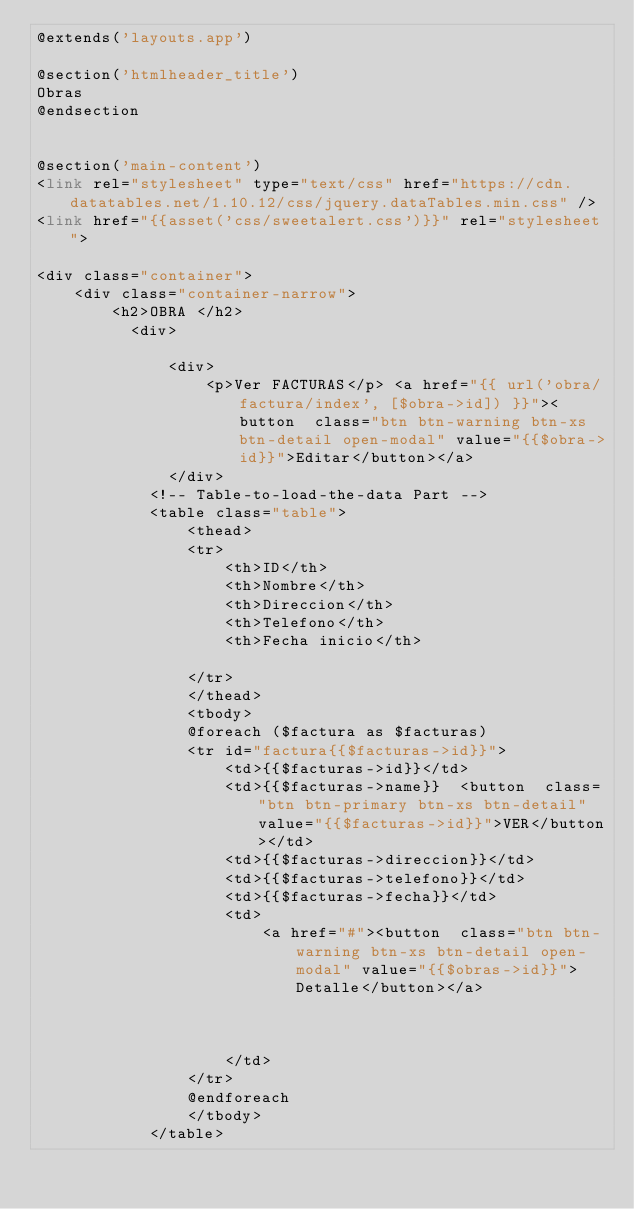Convert code to text. <code><loc_0><loc_0><loc_500><loc_500><_PHP_>@extends('layouts.app')

@section('htmlheader_title')
Obras
@endsection


@section('main-content')
<link rel="stylesheet" type="text/css" href="https://cdn.datatables.net/1.10.12/css/jquery.dataTables.min.css" />
<link href="{{asset('css/sweetalert.css')}}" rel="stylesheet">

<div class="container">
    <div class="container-narrow">
        <h2>OBRA </h2>
          <div>

              <div>
                  <p>Ver FACTURAS</p> <a href="{{ url('obra/factura/index', [$obra->id]) }}"><button  class="btn btn-warning btn-xs btn-detail open-modal" value="{{$obra->id}}">Editar</button></a>
              </div>
            <!-- Table-to-load-the-data Part -->
            <table class="table">
                <thead>
                <tr>
                    <th>ID</th>
                    <th>Nombre</th>
                    <th>Direccion</th>
                    <th>Telefono</th>
                    <th>Fecha inicio</th>

                </tr>
                </thead>
                <tbody>
                @foreach ($factura as $facturas)
                <tr id="factura{{$facturas->id}}">
                    <td>{{$facturas->id}}</td>
                    <td>{{$facturas->name}}  <button  class="btn btn-primary btn-xs btn-detail" value="{{$facturas->id}}">VER</button></td>
                    <td>{{$facturas->direccion}}</td>
                    <td>{{$facturas->telefono}}</td>
                    <td>{{$facturas->fecha}}</td>
                    <td>
                        <a href="#"><button  class="btn btn-warning btn-xs btn-detail open-modal" value="{{$obras->id}}">Detalle</button></a>



                    </td>
                </tr>
                @endforeach
                </tbody>
            </table></code> 